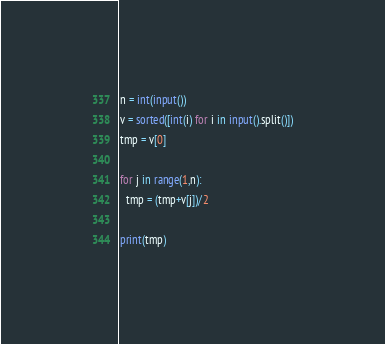Convert code to text. <code><loc_0><loc_0><loc_500><loc_500><_Python_>n = int(input())
v = sorted([int(i) for i in input().split()])
tmp = v[0]

for j in range(1,n):
  tmp = (tmp+v[j])/2
  
print(tmp)</code> 